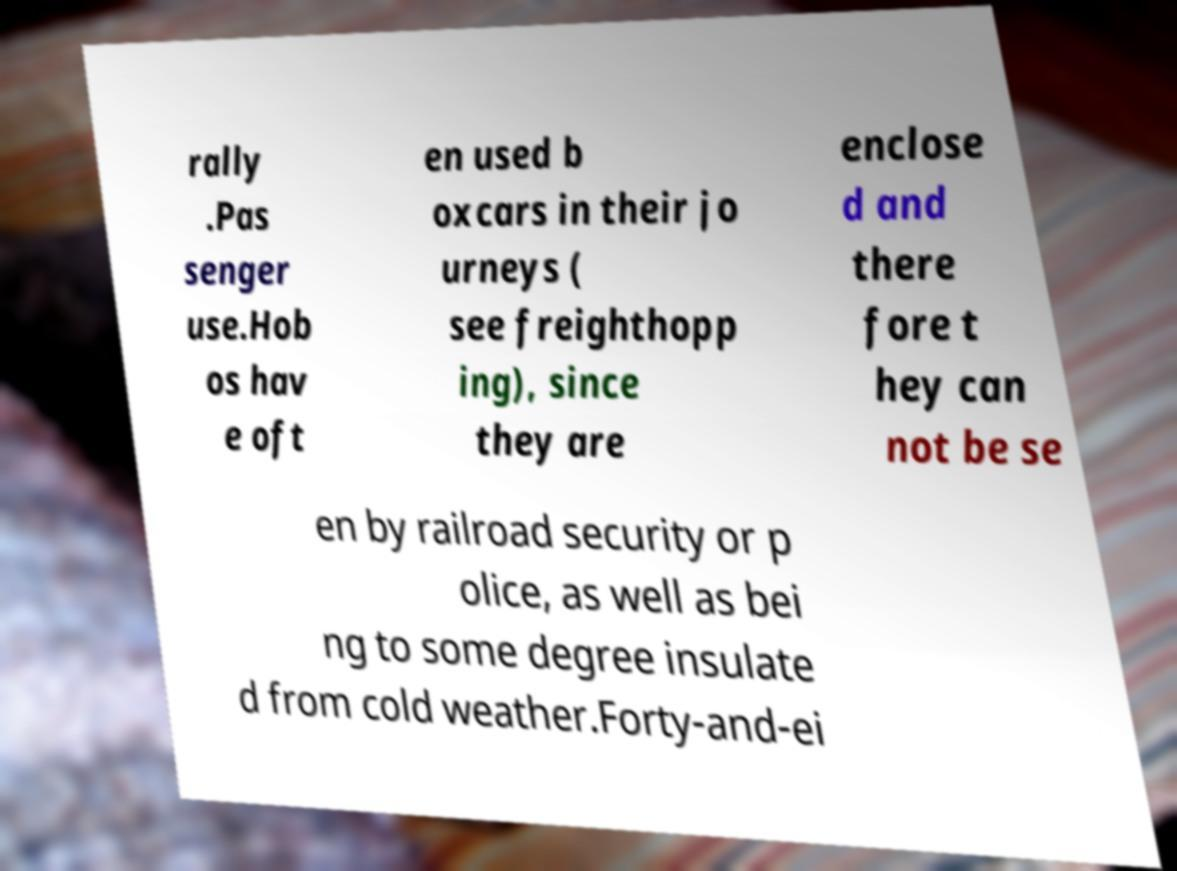There's text embedded in this image that I need extracted. Can you transcribe it verbatim? rally .Pas senger use.Hob os hav e oft en used b oxcars in their jo urneys ( see freighthopp ing), since they are enclose d and there fore t hey can not be se en by railroad security or p olice, as well as bei ng to some degree insulate d from cold weather.Forty-and-ei 